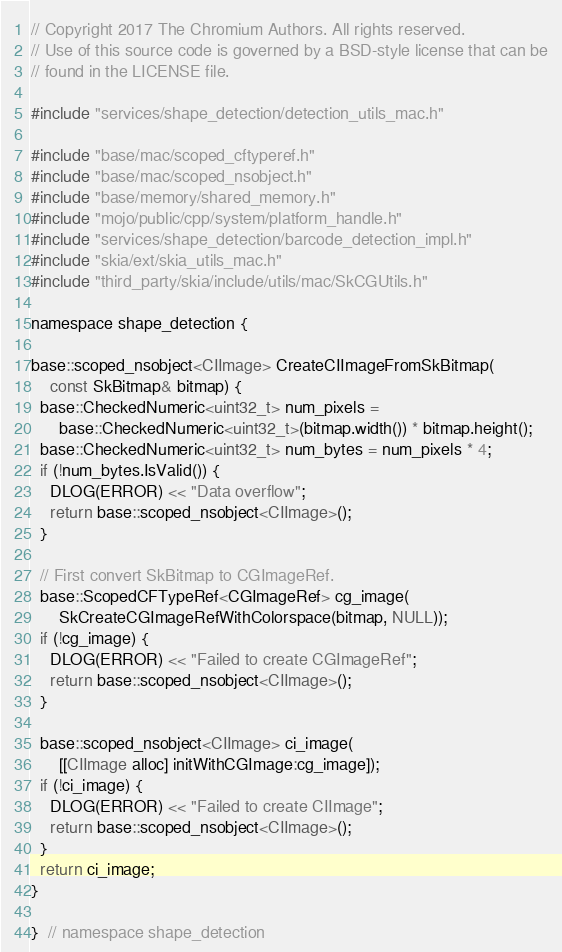<code> <loc_0><loc_0><loc_500><loc_500><_ObjectiveC_>// Copyright 2017 The Chromium Authors. All rights reserved.
// Use of this source code is governed by a BSD-style license that can be
// found in the LICENSE file.

#include "services/shape_detection/detection_utils_mac.h"

#include "base/mac/scoped_cftyperef.h"
#include "base/mac/scoped_nsobject.h"
#include "base/memory/shared_memory.h"
#include "mojo/public/cpp/system/platform_handle.h"
#include "services/shape_detection/barcode_detection_impl.h"
#include "skia/ext/skia_utils_mac.h"
#include "third_party/skia/include/utils/mac/SkCGUtils.h"

namespace shape_detection {

base::scoped_nsobject<CIImage> CreateCIImageFromSkBitmap(
    const SkBitmap& bitmap) {
  base::CheckedNumeric<uint32_t> num_pixels =
      base::CheckedNumeric<uint32_t>(bitmap.width()) * bitmap.height();
  base::CheckedNumeric<uint32_t> num_bytes = num_pixels * 4;
  if (!num_bytes.IsValid()) {
    DLOG(ERROR) << "Data overflow";
    return base::scoped_nsobject<CIImage>();
  }

  // First convert SkBitmap to CGImageRef.
  base::ScopedCFTypeRef<CGImageRef> cg_image(
      SkCreateCGImageRefWithColorspace(bitmap, NULL));
  if (!cg_image) {
    DLOG(ERROR) << "Failed to create CGImageRef";
    return base::scoped_nsobject<CIImage>();
  }

  base::scoped_nsobject<CIImage> ci_image(
      [[CIImage alloc] initWithCGImage:cg_image]);
  if (!ci_image) {
    DLOG(ERROR) << "Failed to create CIImage";
    return base::scoped_nsobject<CIImage>();
  }
  return ci_image;
}

}  // namespace shape_detection
</code> 